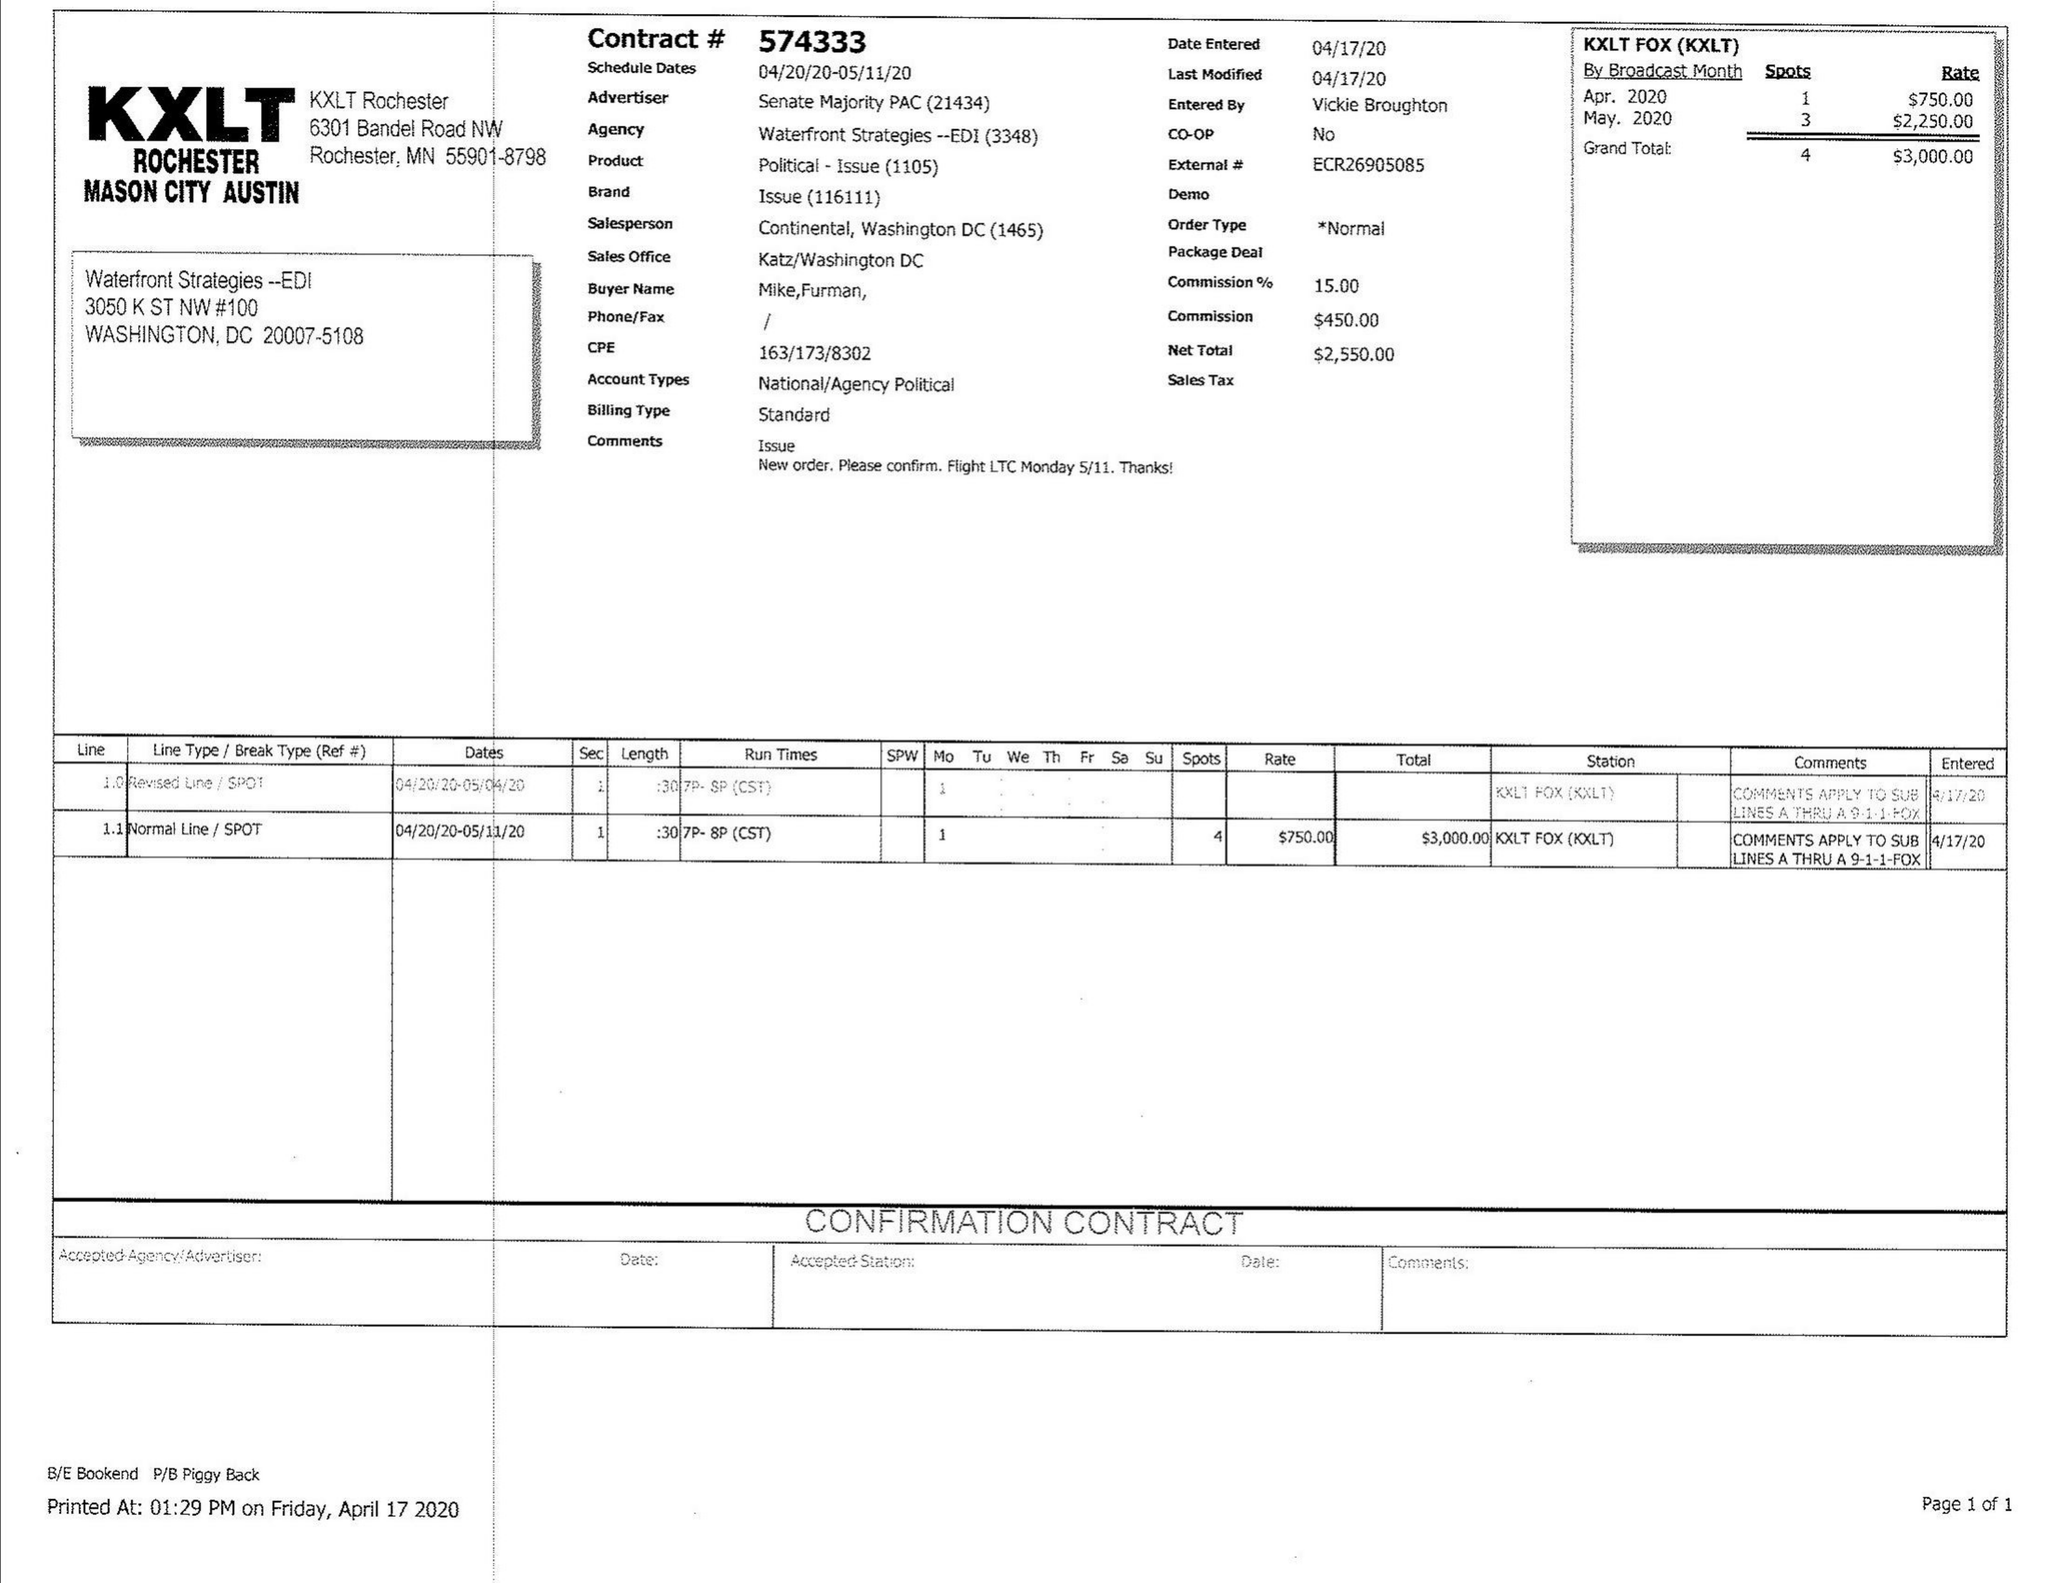What is the value for the gross_amount?
Answer the question using a single word or phrase. 3000.00 